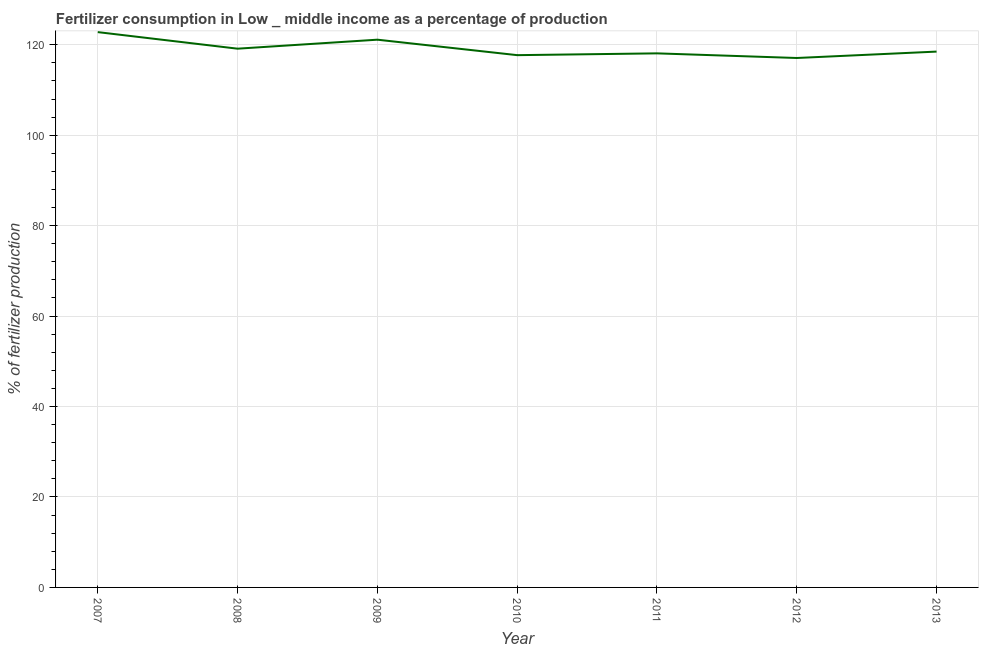What is the amount of fertilizer consumption in 2012?
Offer a terse response. 117.07. Across all years, what is the maximum amount of fertilizer consumption?
Make the answer very short. 122.79. Across all years, what is the minimum amount of fertilizer consumption?
Your answer should be very brief. 117.07. What is the sum of the amount of fertilizer consumption?
Ensure brevity in your answer.  834.4. What is the difference between the amount of fertilizer consumption in 2009 and 2010?
Offer a terse response. 3.42. What is the average amount of fertilizer consumption per year?
Your answer should be compact. 119.2. What is the median amount of fertilizer consumption?
Ensure brevity in your answer.  118.49. What is the ratio of the amount of fertilizer consumption in 2007 to that in 2013?
Make the answer very short. 1.04. Is the amount of fertilizer consumption in 2011 less than that in 2012?
Provide a short and direct response. No. What is the difference between the highest and the second highest amount of fertilizer consumption?
Your answer should be compact. 1.67. Is the sum of the amount of fertilizer consumption in 2011 and 2013 greater than the maximum amount of fertilizer consumption across all years?
Your answer should be compact. Yes. What is the difference between the highest and the lowest amount of fertilizer consumption?
Offer a very short reply. 5.72. Does the amount of fertilizer consumption monotonically increase over the years?
Make the answer very short. No. How many years are there in the graph?
Keep it short and to the point. 7. What is the difference between two consecutive major ticks on the Y-axis?
Provide a succinct answer. 20. What is the title of the graph?
Keep it short and to the point. Fertilizer consumption in Low _ middle income as a percentage of production. What is the label or title of the Y-axis?
Your response must be concise. % of fertilizer production. What is the % of fertilizer production of 2007?
Your response must be concise. 122.79. What is the % of fertilizer production in 2008?
Your answer should be compact. 119.13. What is the % of fertilizer production in 2009?
Provide a short and direct response. 121.12. What is the % of fertilizer production of 2010?
Provide a short and direct response. 117.7. What is the % of fertilizer production in 2011?
Keep it short and to the point. 118.1. What is the % of fertilizer production in 2012?
Make the answer very short. 117.07. What is the % of fertilizer production in 2013?
Offer a terse response. 118.49. What is the difference between the % of fertilizer production in 2007 and 2008?
Offer a very short reply. 3.66. What is the difference between the % of fertilizer production in 2007 and 2009?
Provide a succinct answer. 1.67. What is the difference between the % of fertilizer production in 2007 and 2010?
Your response must be concise. 5.09. What is the difference between the % of fertilizer production in 2007 and 2011?
Ensure brevity in your answer.  4.7. What is the difference between the % of fertilizer production in 2007 and 2012?
Make the answer very short. 5.72. What is the difference between the % of fertilizer production in 2007 and 2013?
Your answer should be compact. 4.31. What is the difference between the % of fertilizer production in 2008 and 2009?
Your answer should be very brief. -1.99. What is the difference between the % of fertilizer production in 2008 and 2010?
Make the answer very short. 1.43. What is the difference between the % of fertilizer production in 2008 and 2011?
Provide a short and direct response. 1.03. What is the difference between the % of fertilizer production in 2008 and 2012?
Your answer should be very brief. 2.06. What is the difference between the % of fertilizer production in 2008 and 2013?
Ensure brevity in your answer.  0.64. What is the difference between the % of fertilizer production in 2009 and 2010?
Ensure brevity in your answer.  3.42. What is the difference between the % of fertilizer production in 2009 and 2011?
Provide a short and direct response. 3.02. What is the difference between the % of fertilizer production in 2009 and 2012?
Your answer should be very brief. 4.05. What is the difference between the % of fertilizer production in 2009 and 2013?
Keep it short and to the point. 2.63. What is the difference between the % of fertilizer production in 2010 and 2011?
Make the answer very short. -0.4. What is the difference between the % of fertilizer production in 2010 and 2012?
Keep it short and to the point. 0.63. What is the difference between the % of fertilizer production in 2010 and 2013?
Your answer should be very brief. -0.79. What is the difference between the % of fertilizer production in 2011 and 2012?
Keep it short and to the point. 1.02. What is the difference between the % of fertilizer production in 2011 and 2013?
Your response must be concise. -0.39. What is the difference between the % of fertilizer production in 2012 and 2013?
Give a very brief answer. -1.42. What is the ratio of the % of fertilizer production in 2007 to that in 2008?
Offer a very short reply. 1.03. What is the ratio of the % of fertilizer production in 2007 to that in 2010?
Your answer should be compact. 1.04. What is the ratio of the % of fertilizer production in 2007 to that in 2012?
Your answer should be compact. 1.05. What is the ratio of the % of fertilizer production in 2007 to that in 2013?
Give a very brief answer. 1.04. What is the ratio of the % of fertilizer production in 2008 to that in 2010?
Ensure brevity in your answer.  1.01. What is the ratio of the % of fertilizer production in 2008 to that in 2011?
Make the answer very short. 1.01. What is the ratio of the % of fertilizer production in 2009 to that in 2011?
Your response must be concise. 1.03. What is the ratio of the % of fertilizer production in 2009 to that in 2012?
Your answer should be very brief. 1.03. What is the ratio of the % of fertilizer production in 2009 to that in 2013?
Make the answer very short. 1.02. What is the ratio of the % of fertilizer production in 2011 to that in 2013?
Your response must be concise. 1. 